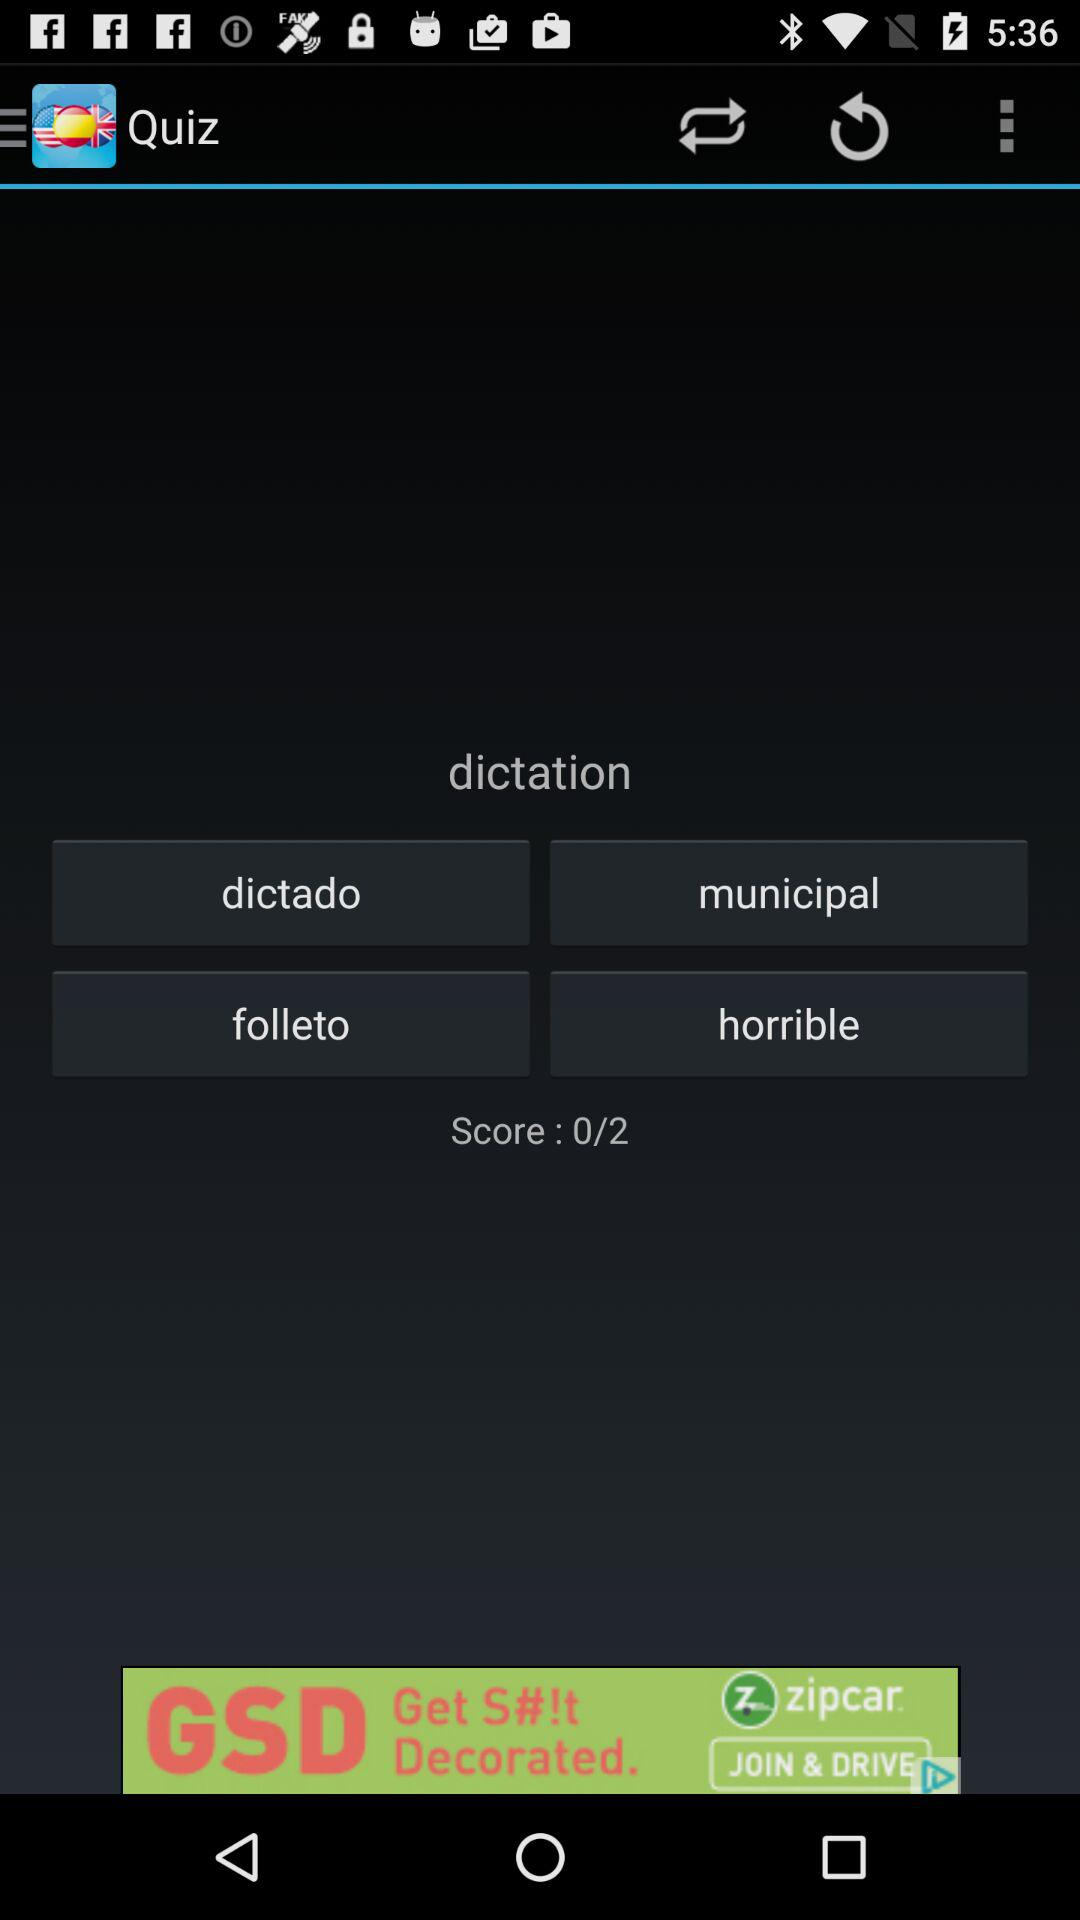What is the score? The score is 0. 